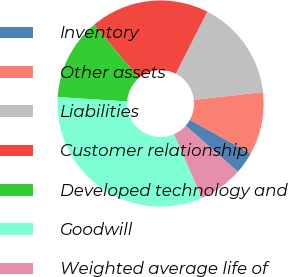Convert chart. <chart><loc_0><loc_0><loc_500><loc_500><pie_chart><fcel>Inventory<fcel>Other assets<fcel>Liabilities<fcel>Customer relationship<fcel>Developed technology and<fcel>Goodwill<fcel>Weighted average life of<nl><fcel>3.46%<fcel>9.82%<fcel>15.75%<fcel>18.66%<fcel>12.83%<fcel>32.58%<fcel>6.91%<nl></chart> 